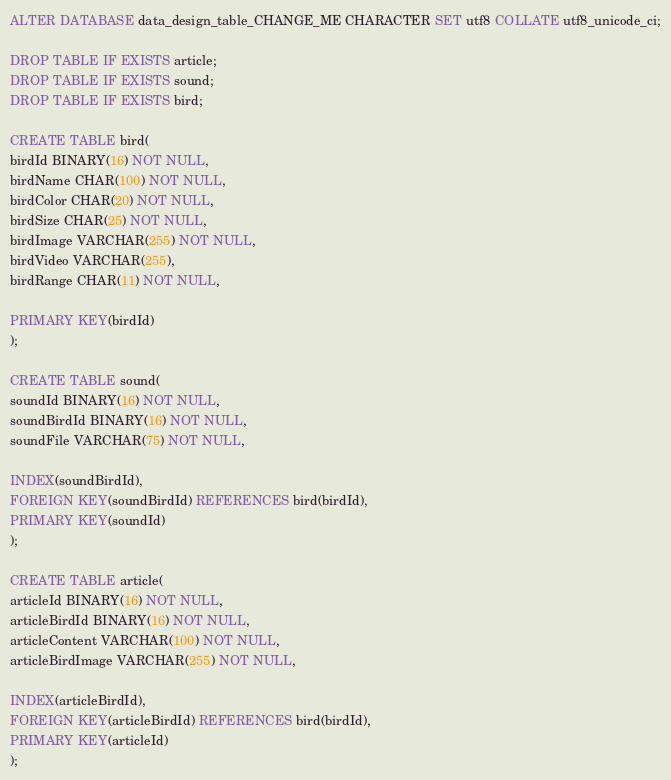Convert code to text. <code><loc_0><loc_0><loc_500><loc_500><_SQL_>ALTER DATABASE data_design_table_CHANGE_ME CHARACTER SET utf8 COLLATE utf8_unicode_ci;

DROP TABLE IF EXISTS article;
DROP TABLE IF EXISTS sound;
DROP TABLE IF EXISTS bird;

CREATE TABLE bird(
birdId BINARY(16) NOT NULL,
birdName CHAR(100) NOT NULL,
birdColor CHAR(20) NOT NULL,
birdSize CHAR(25) NOT NULL,
birdImage VARCHAR(255) NOT NULL,
birdVideo VARCHAR(255),
birdRange CHAR(11) NOT NULL,

PRIMARY KEY(birdId)
);

CREATE TABLE sound(
soundId BINARY(16) NOT NULL,
soundBirdId BINARY(16) NOT NULL,
soundFile VARCHAR(75) NOT NULL,

INDEX(soundBirdId),
FOREIGN KEY(soundBirdId) REFERENCES bird(birdId),
PRIMARY KEY(soundId)
);

CREATE TABLE article(
articleId BINARY(16) NOT NULL,
articleBirdId BINARY(16) NOT NULL,
articleContent VARCHAR(100) NOT NULL,
articleBirdImage VARCHAR(255) NOT NULL,

INDEX(articleBirdId),
FOREIGN KEY(articleBirdId) REFERENCES bird(birdId),
PRIMARY KEY(articleId)
);</code> 